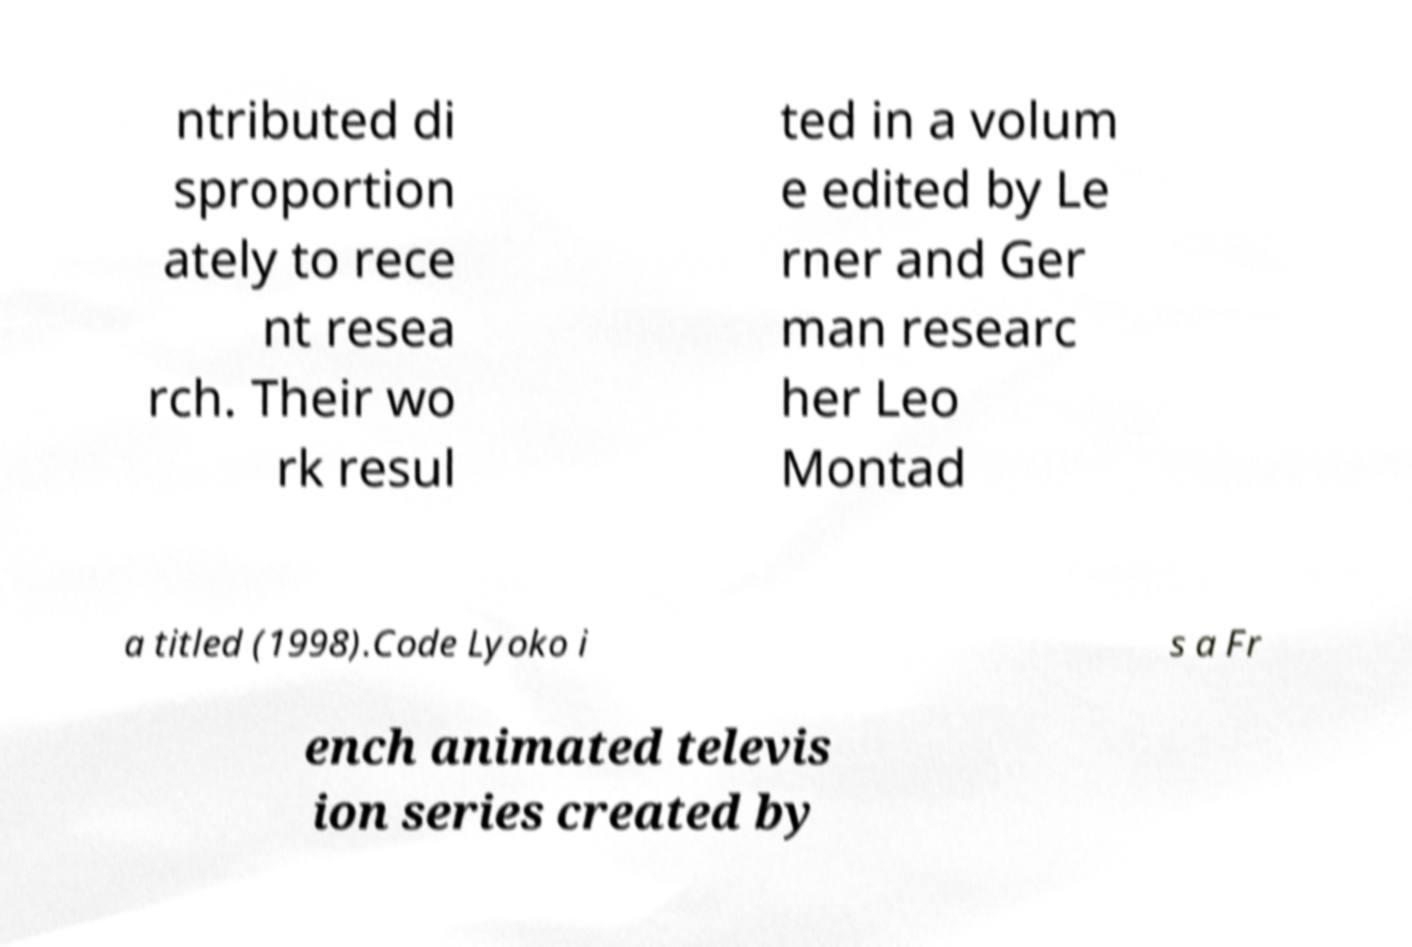What messages or text are displayed in this image? I need them in a readable, typed format. ntributed di sproportion ately to rece nt resea rch. Their wo rk resul ted in a volum e edited by Le rner and Ger man researc her Leo Montad a titled (1998).Code Lyoko i s a Fr ench animated televis ion series created by 